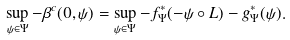<formula> <loc_0><loc_0><loc_500><loc_500>\sup _ { \psi \in \Psi } - \beta ^ { c } ( 0 , \psi ) = \sup _ { \psi \in \Psi } - f ^ { * } _ { \Psi } ( - \psi \circ L ) - g ^ { * } _ { \Psi } ( \psi ) .</formula> 